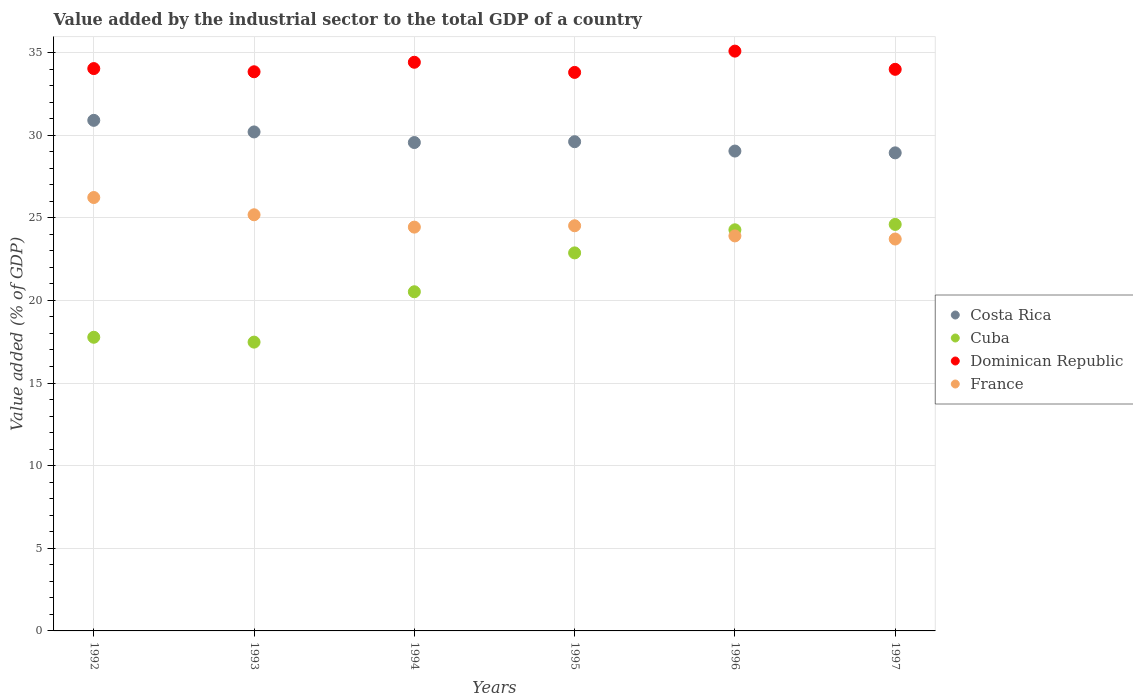How many different coloured dotlines are there?
Your response must be concise. 4. Is the number of dotlines equal to the number of legend labels?
Make the answer very short. Yes. What is the value added by the industrial sector to the total GDP in Dominican Republic in 1997?
Make the answer very short. 33.98. Across all years, what is the maximum value added by the industrial sector to the total GDP in Cuba?
Give a very brief answer. 24.6. Across all years, what is the minimum value added by the industrial sector to the total GDP in France?
Provide a succinct answer. 23.71. What is the total value added by the industrial sector to the total GDP in France in the graph?
Provide a succinct answer. 147.98. What is the difference between the value added by the industrial sector to the total GDP in Costa Rica in 1996 and that in 1997?
Provide a short and direct response. 0.11. What is the difference between the value added by the industrial sector to the total GDP in France in 1994 and the value added by the industrial sector to the total GDP in Dominican Republic in 1995?
Offer a very short reply. -9.36. What is the average value added by the industrial sector to the total GDP in Cuba per year?
Make the answer very short. 21.25. In the year 1997, what is the difference between the value added by the industrial sector to the total GDP in Dominican Republic and value added by the industrial sector to the total GDP in Costa Rica?
Make the answer very short. 5.05. In how many years, is the value added by the industrial sector to the total GDP in France greater than 7 %?
Your response must be concise. 6. What is the ratio of the value added by the industrial sector to the total GDP in Costa Rica in 1993 to that in 1995?
Give a very brief answer. 1.02. What is the difference between the highest and the second highest value added by the industrial sector to the total GDP in Dominican Republic?
Ensure brevity in your answer.  0.67. What is the difference between the highest and the lowest value added by the industrial sector to the total GDP in France?
Make the answer very short. 2.51. In how many years, is the value added by the industrial sector to the total GDP in Cuba greater than the average value added by the industrial sector to the total GDP in Cuba taken over all years?
Ensure brevity in your answer.  3. Is the sum of the value added by the industrial sector to the total GDP in Cuba in 1992 and 1994 greater than the maximum value added by the industrial sector to the total GDP in Dominican Republic across all years?
Provide a succinct answer. Yes. Is it the case that in every year, the sum of the value added by the industrial sector to the total GDP in Cuba and value added by the industrial sector to the total GDP in Dominican Republic  is greater than the sum of value added by the industrial sector to the total GDP in Costa Rica and value added by the industrial sector to the total GDP in France?
Provide a short and direct response. No. Is the value added by the industrial sector to the total GDP in Cuba strictly greater than the value added by the industrial sector to the total GDP in Dominican Republic over the years?
Keep it short and to the point. No. How many dotlines are there?
Make the answer very short. 4. How many years are there in the graph?
Your answer should be very brief. 6. How many legend labels are there?
Your response must be concise. 4. How are the legend labels stacked?
Your answer should be very brief. Vertical. What is the title of the graph?
Keep it short and to the point. Value added by the industrial sector to the total GDP of a country. Does "Seychelles" appear as one of the legend labels in the graph?
Your response must be concise. No. What is the label or title of the Y-axis?
Provide a short and direct response. Value added (% of GDP). What is the Value added (% of GDP) of Costa Rica in 1992?
Offer a terse response. 30.9. What is the Value added (% of GDP) of Cuba in 1992?
Your response must be concise. 17.77. What is the Value added (% of GDP) in Dominican Republic in 1992?
Provide a short and direct response. 34.03. What is the Value added (% of GDP) in France in 1992?
Give a very brief answer. 26.23. What is the Value added (% of GDP) in Costa Rica in 1993?
Offer a very short reply. 30.19. What is the Value added (% of GDP) in Cuba in 1993?
Provide a short and direct response. 17.48. What is the Value added (% of GDP) of Dominican Republic in 1993?
Your response must be concise. 33.84. What is the Value added (% of GDP) of France in 1993?
Your answer should be compact. 25.18. What is the Value added (% of GDP) in Costa Rica in 1994?
Your answer should be compact. 29.55. What is the Value added (% of GDP) of Cuba in 1994?
Provide a succinct answer. 20.52. What is the Value added (% of GDP) of Dominican Republic in 1994?
Ensure brevity in your answer.  34.41. What is the Value added (% of GDP) in France in 1994?
Offer a very short reply. 24.43. What is the Value added (% of GDP) in Costa Rica in 1995?
Give a very brief answer. 29.6. What is the Value added (% of GDP) in Cuba in 1995?
Provide a succinct answer. 22.88. What is the Value added (% of GDP) of Dominican Republic in 1995?
Give a very brief answer. 33.8. What is the Value added (% of GDP) of France in 1995?
Your response must be concise. 24.52. What is the Value added (% of GDP) in Costa Rica in 1996?
Your response must be concise. 29.04. What is the Value added (% of GDP) of Cuba in 1996?
Your answer should be very brief. 24.27. What is the Value added (% of GDP) of Dominican Republic in 1996?
Your response must be concise. 35.08. What is the Value added (% of GDP) in France in 1996?
Keep it short and to the point. 23.9. What is the Value added (% of GDP) in Costa Rica in 1997?
Provide a succinct answer. 28.93. What is the Value added (% of GDP) in Cuba in 1997?
Provide a succinct answer. 24.6. What is the Value added (% of GDP) in Dominican Republic in 1997?
Offer a terse response. 33.98. What is the Value added (% of GDP) of France in 1997?
Give a very brief answer. 23.71. Across all years, what is the maximum Value added (% of GDP) of Costa Rica?
Your response must be concise. 30.9. Across all years, what is the maximum Value added (% of GDP) of Cuba?
Provide a short and direct response. 24.6. Across all years, what is the maximum Value added (% of GDP) in Dominican Republic?
Offer a very short reply. 35.08. Across all years, what is the maximum Value added (% of GDP) in France?
Your answer should be compact. 26.23. Across all years, what is the minimum Value added (% of GDP) in Costa Rica?
Give a very brief answer. 28.93. Across all years, what is the minimum Value added (% of GDP) in Cuba?
Keep it short and to the point. 17.48. Across all years, what is the minimum Value added (% of GDP) in Dominican Republic?
Make the answer very short. 33.8. Across all years, what is the minimum Value added (% of GDP) in France?
Make the answer very short. 23.71. What is the total Value added (% of GDP) in Costa Rica in the graph?
Make the answer very short. 178.21. What is the total Value added (% of GDP) of Cuba in the graph?
Ensure brevity in your answer.  127.51. What is the total Value added (% of GDP) of Dominican Republic in the graph?
Ensure brevity in your answer.  205.14. What is the total Value added (% of GDP) of France in the graph?
Provide a short and direct response. 147.97. What is the difference between the Value added (% of GDP) in Costa Rica in 1992 and that in 1993?
Keep it short and to the point. 0.7. What is the difference between the Value added (% of GDP) of Cuba in 1992 and that in 1993?
Make the answer very short. 0.29. What is the difference between the Value added (% of GDP) of Dominican Republic in 1992 and that in 1993?
Offer a very short reply. 0.19. What is the difference between the Value added (% of GDP) in France in 1992 and that in 1993?
Your answer should be compact. 1.04. What is the difference between the Value added (% of GDP) of Costa Rica in 1992 and that in 1994?
Make the answer very short. 1.34. What is the difference between the Value added (% of GDP) of Cuba in 1992 and that in 1994?
Your response must be concise. -2.75. What is the difference between the Value added (% of GDP) of Dominican Republic in 1992 and that in 1994?
Offer a terse response. -0.38. What is the difference between the Value added (% of GDP) of France in 1992 and that in 1994?
Your answer should be very brief. 1.79. What is the difference between the Value added (% of GDP) of Costa Rica in 1992 and that in 1995?
Give a very brief answer. 1.29. What is the difference between the Value added (% of GDP) of Cuba in 1992 and that in 1995?
Your answer should be very brief. -5.11. What is the difference between the Value added (% of GDP) in Dominican Republic in 1992 and that in 1995?
Provide a succinct answer. 0.23. What is the difference between the Value added (% of GDP) in France in 1992 and that in 1995?
Ensure brevity in your answer.  1.71. What is the difference between the Value added (% of GDP) of Costa Rica in 1992 and that in 1996?
Provide a short and direct response. 1.86. What is the difference between the Value added (% of GDP) of Cuba in 1992 and that in 1996?
Your answer should be very brief. -6.5. What is the difference between the Value added (% of GDP) of Dominican Republic in 1992 and that in 1996?
Provide a succinct answer. -1.06. What is the difference between the Value added (% of GDP) in France in 1992 and that in 1996?
Provide a short and direct response. 2.32. What is the difference between the Value added (% of GDP) in Costa Rica in 1992 and that in 1997?
Provide a succinct answer. 1.97. What is the difference between the Value added (% of GDP) of Cuba in 1992 and that in 1997?
Ensure brevity in your answer.  -6.83. What is the difference between the Value added (% of GDP) in Dominican Republic in 1992 and that in 1997?
Your response must be concise. 0.05. What is the difference between the Value added (% of GDP) in France in 1992 and that in 1997?
Offer a very short reply. 2.51. What is the difference between the Value added (% of GDP) of Costa Rica in 1993 and that in 1994?
Make the answer very short. 0.64. What is the difference between the Value added (% of GDP) in Cuba in 1993 and that in 1994?
Ensure brevity in your answer.  -3.05. What is the difference between the Value added (% of GDP) in Dominican Republic in 1993 and that in 1994?
Give a very brief answer. -0.57. What is the difference between the Value added (% of GDP) of France in 1993 and that in 1994?
Provide a short and direct response. 0.75. What is the difference between the Value added (% of GDP) in Costa Rica in 1993 and that in 1995?
Your answer should be compact. 0.59. What is the difference between the Value added (% of GDP) in Cuba in 1993 and that in 1995?
Provide a succinct answer. -5.4. What is the difference between the Value added (% of GDP) of Dominican Republic in 1993 and that in 1995?
Provide a short and direct response. 0.04. What is the difference between the Value added (% of GDP) in France in 1993 and that in 1995?
Your answer should be compact. 0.66. What is the difference between the Value added (% of GDP) of Costa Rica in 1993 and that in 1996?
Keep it short and to the point. 1.16. What is the difference between the Value added (% of GDP) of Cuba in 1993 and that in 1996?
Ensure brevity in your answer.  -6.8. What is the difference between the Value added (% of GDP) in Dominican Republic in 1993 and that in 1996?
Your answer should be compact. -1.25. What is the difference between the Value added (% of GDP) of France in 1993 and that in 1996?
Make the answer very short. 1.28. What is the difference between the Value added (% of GDP) of Costa Rica in 1993 and that in 1997?
Make the answer very short. 1.27. What is the difference between the Value added (% of GDP) in Cuba in 1993 and that in 1997?
Ensure brevity in your answer.  -7.12. What is the difference between the Value added (% of GDP) in Dominican Republic in 1993 and that in 1997?
Provide a succinct answer. -0.15. What is the difference between the Value added (% of GDP) of France in 1993 and that in 1997?
Provide a succinct answer. 1.47. What is the difference between the Value added (% of GDP) in Costa Rica in 1994 and that in 1995?
Provide a succinct answer. -0.05. What is the difference between the Value added (% of GDP) of Cuba in 1994 and that in 1995?
Give a very brief answer. -2.35. What is the difference between the Value added (% of GDP) of Dominican Republic in 1994 and that in 1995?
Your answer should be compact. 0.61. What is the difference between the Value added (% of GDP) of France in 1994 and that in 1995?
Make the answer very short. -0.08. What is the difference between the Value added (% of GDP) of Costa Rica in 1994 and that in 1996?
Provide a short and direct response. 0.52. What is the difference between the Value added (% of GDP) in Cuba in 1994 and that in 1996?
Your answer should be compact. -3.75. What is the difference between the Value added (% of GDP) in Dominican Republic in 1994 and that in 1996?
Provide a succinct answer. -0.67. What is the difference between the Value added (% of GDP) of France in 1994 and that in 1996?
Your answer should be very brief. 0.53. What is the difference between the Value added (% of GDP) in Costa Rica in 1994 and that in 1997?
Make the answer very short. 0.62. What is the difference between the Value added (% of GDP) of Cuba in 1994 and that in 1997?
Make the answer very short. -4.08. What is the difference between the Value added (% of GDP) of Dominican Republic in 1994 and that in 1997?
Provide a succinct answer. 0.43. What is the difference between the Value added (% of GDP) in France in 1994 and that in 1997?
Provide a short and direct response. 0.72. What is the difference between the Value added (% of GDP) of Costa Rica in 1995 and that in 1996?
Offer a terse response. 0.57. What is the difference between the Value added (% of GDP) in Cuba in 1995 and that in 1996?
Keep it short and to the point. -1.4. What is the difference between the Value added (% of GDP) in Dominican Republic in 1995 and that in 1996?
Provide a short and direct response. -1.29. What is the difference between the Value added (% of GDP) in France in 1995 and that in 1996?
Give a very brief answer. 0.61. What is the difference between the Value added (% of GDP) of Costa Rica in 1995 and that in 1997?
Offer a terse response. 0.67. What is the difference between the Value added (% of GDP) in Cuba in 1995 and that in 1997?
Offer a terse response. -1.72. What is the difference between the Value added (% of GDP) in Dominican Republic in 1995 and that in 1997?
Keep it short and to the point. -0.19. What is the difference between the Value added (% of GDP) in France in 1995 and that in 1997?
Offer a very short reply. 0.8. What is the difference between the Value added (% of GDP) in Costa Rica in 1996 and that in 1997?
Provide a succinct answer. 0.11. What is the difference between the Value added (% of GDP) in Cuba in 1996 and that in 1997?
Offer a very short reply. -0.33. What is the difference between the Value added (% of GDP) of Dominican Republic in 1996 and that in 1997?
Give a very brief answer. 1.1. What is the difference between the Value added (% of GDP) of France in 1996 and that in 1997?
Keep it short and to the point. 0.19. What is the difference between the Value added (% of GDP) in Costa Rica in 1992 and the Value added (% of GDP) in Cuba in 1993?
Your answer should be very brief. 13.42. What is the difference between the Value added (% of GDP) in Costa Rica in 1992 and the Value added (% of GDP) in Dominican Republic in 1993?
Make the answer very short. -2.94. What is the difference between the Value added (% of GDP) of Costa Rica in 1992 and the Value added (% of GDP) of France in 1993?
Provide a short and direct response. 5.71. What is the difference between the Value added (% of GDP) in Cuba in 1992 and the Value added (% of GDP) in Dominican Republic in 1993?
Keep it short and to the point. -16.07. What is the difference between the Value added (% of GDP) of Cuba in 1992 and the Value added (% of GDP) of France in 1993?
Your answer should be very brief. -7.41. What is the difference between the Value added (% of GDP) of Dominican Republic in 1992 and the Value added (% of GDP) of France in 1993?
Make the answer very short. 8.85. What is the difference between the Value added (% of GDP) in Costa Rica in 1992 and the Value added (% of GDP) in Cuba in 1994?
Offer a terse response. 10.37. What is the difference between the Value added (% of GDP) of Costa Rica in 1992 and the Value added (% of GDP) of Dominican Republic in 1994?
Your response must be concise. -3.51. What is the difference between the Value added (% of GDP) in Costa Rica in 1992 and the Value added (% of GDP) in France in 1994?
Ensure brevity in your answer.  6.46. What is the difference between the Value added (% of GDP) in Cuba in 1992 and the Value added (% of GDP) in Dominican Republic in 1994?
Ensure brevity in your answer.  -16.64. What is the difference between the Value added (% of GDP) of Cuba in 1992 and the Value added (% of GDP) of France in 1994?
Offer a terse response. -6.67. What is the difference between the Value added (% of GDP) of Dominican Republic in 1992 and the Value added (% of GDP) of France in 1994?
Give a very brief answer. 9.59. What is the difference between the Value added (% of GDP) of Costa Rica in 1992 and the Value added (% of GDP) of Cuba in 1995?
Your answer should be compact. 8.02. What is the difference between the Value added (% of GDP) in Costa Rica in 1992 and the Value added (% of GDP) in Dominican Republic in 1995?
Ensure brevity in your answer.  -2.9. What is the difference between the Value added (% of GDP) of Costa Rica in 1992 and the Value added (% of GDP) of France in 1995?
Your answer should be compact. 6.38. What is the difference between the Value added (% of GDP) in Cuba in 1992 and the Value added (% of GDP) in Dominican Republic in 1995?
Your answer should be compact. -16.03. What is the difference between the Value added (% of GDP) in Cuba in 1992 and the Value added (% of GDP) in France in 1995?
Ensure brevity in your answer.  -6.75. What is the difference between the Value added (% of GDP) of Dominican Republic in 1992 and the Value added (% of GDP) of France in 1995?
Your answer should be compact. 9.51. What is the difference between the Value added (% of GDP) in Costa Rica in 1992 and the Value added (% of GDP) in Cuba in 1996?
Provide a short and direct response. 6.62. What is the difference between the Value added (% of GDP) in Costa Rica in 1992 and the Value added (% of GDP) in Dominican Republic in 1996?
Give a very brief answer. -4.19. What is the difference between the Value added (% of GDP) of Costa Rica in 1992 and the Value added (% of GDP) of France in 1996?
Your response must be concise. 6.99. What is the difference between the Value added (% of GDP) of Cuba in 1992 and the Value added (% of GDP) of Dominican Republic in 1996?
Give a very brief answer. -17.31. What is the difference between the Value added (% of GDP) in Cuba in 1992 and the Value added (% of GDP) in France in 1996?
Offer a terse response. -6.13. What is the difference between the Value added (% of GDP) in Dominican Republic in 1992 and the Value added (% of GDP) in France in 1996?
Offer a terse response. 10.13. What is the difference between the Value added (% of GDP) of Costa Rica in 1992 and the Value added (% of GDP) of Cuba in 1997?
Your response must be concise. 6.3. What is the difference between the Value added (% of GDP) in Costa Rica in 1992 and the Value added (% of GDP) in Dominican Republic in 1997?
Ensure brevity in your answer.  -3.09. What is the difference between the Value added (% of GDP) of Costa Rica in 1992 and the Value added (% of GDP) of France in 1997?
Keep it short and to the point. 7.18. What is the difference between the Value added (% of GDP) of Cuba in 1992 and the Value added (% of GDP) of Dominican Republic in 1997?
Give a very brief answer. -16.21. What is the difference between the Value added (% of GDP) in Cuba in 1992 and the Value added (% of GDP) in France in 1997?
Make the answer very short. -5.94. What is the difference between the Value added (% of GDP) of Dominican Republic in 1992 and the Value added (% of GDP) of France in 1997?
Ensure brevity in your answer.  10.31. What is the difference between the Value added (% of GDP) in Costa Rica in 1993 and the Value added (% of GDP) in Cuba in 1994?
Keep it short and to the point. 9.67. What is the difference between the Value added (% of GDP) in Costa Rica in 1993 and the Value added (% of GDP) in Dominican Republic in 1994?
Your answer should be very brief. -4.22. What is the difference between the Value added (% of GDP) of Costa Rica in 1993 and the Value added (% of GDP) of France in 1994?
Provide a short and direct response. 5.76. What is the difference between the Value added (% of GDP) in Cuba in 1993 and the Value added (% of GDP) in Dominican Republic in 1994?
Your response must be concise. -16.93. What is the difference between the Value added (% of GDP) of Cuba in 1993 and the Value added (% of GDP) of France in 1994?
Give a very brief answer. -6.96. What is the difference between the Value added (% of GDP) in Dominican Republic in 1993 and the Value added (% of GDP) in France in 1994?
Your answer should be very brief. 9.4. What is the difference between the Value added (% of GDP) of Costa Rica in 1993 and the Value added (% of GDP) of Cuba in 1995?
Ensure brevity in your answer.  7.32. What is the difference between the Value added (% of GDP) in Costa Rica in 1993 and the Value added (% of GDP) in Dominican Republic in 1995?
Your response must be concise. -3.6. What is the difference between the Value added (% of GDP) of Costa Rica in 1993 and the Value added (% of GDP) of France in 1995?
Provide a short and direct response. 5.68. What is the difference between the Value added (% of GDP) of Cuba in 1993 and the Value added (% of GDP) of Dominican Republic in 1995?
Make the answer very short. -16.32. What is the difference between the Value added (% of GDP) in Cuba in 1993 and the Value added (% of GDP) in France in 1995?
Ensure brevity in your answer.  -7.04. What is the difference between the Value added (% of GDP) of Dominican Republic in 1993 and the Value added (% of GDP) of France in 1995?
Ensure brevity in your answer.  9.32. What is the difference between the Value added (% of GDP) of Costa Rica in 1993 and the Value added (% of GDP) of Cuba in 1996?
Your response must be concise. 5.92. What is the difference between the Value added (% of GDP) of Costa Rica in 1993 and the Value added (% of GDP) of Dominican Republic in 1996?
Keep it short and to the point. -4.89. What is the difference between the Value added (% of GDP) in Costa Rica in 1993 and the Value added (% of GDP) in France in 1996?
Offer a very short reply. 6.29. What is the difference between the Value added (% of GDP) in Cuba in 1993 and the Value added (% of GDP) in Dominican Republic in 1996?
Your answer should be compact. -17.61. What is the difference between the Value added (% of GDP) of Cuba in 1993 and the Value added (% of GDP) of France in 1996?
Provide a succinct answer. -6.43. What is the difference between the Value added (% of GDP) in Dominican Republic in 1993 and the Value added (% of GDP) in France in 1996?
Your answer should be very brief. 9.93. What is the difference between the Value added (% of GDP) of Costa Rica in 1993 and the Value added (% of GDP) of Cuba in 1997?
Your response must be concise. 5.6. What is the difference between the Value added (% of GDP) in Costa Rica in 1993 and the Value added (% of GDP) in Dominican Republic in 1997?
Your response must be concise. -3.79. What is the difference between the Value added (% of GDP) in Costa Rica in 1993 and the Value added (% of GDP) in France in 1997?
Provide a short and direct response. 6.48. What is the difference between the Value added (% of GDP) in Cuba in 1993 and the Value added (% of GDP) in Dominican Republic in 1997?
Offer a very short reply. -16.51. What is the difference between the Value added (% of GDP) of Cuba in 1993 and the Value added (% of GDP) of France in 1997?
Give a very brief answer. -6.24. What is the difference between the Value added (% of GDP) of Dominican Republic in 1993 and the Value added (% of GDP) of France in 1997?
Give a very brief answer. 10.12. What is the difference between the Value added (% of GDP) of Costa Rica in 1994 and the Value added (% of GDP) of Cuba in 1995?
Provide a succinct answer. 6.68. What is the difference between the Value added (% of GDP) in Costa Rica in 1994 and the Value added (% of GDP) in Dominican Republic in 1995?
Your response must be concise. -4.24. What is the difference between the Value added (% of GDP) of Costa Rica in 1994 and the Value added (% of GDP) of France in 1995?
Your response must be concise. 5.04. What is the difference between the Value added (% of GDP) in Cuba in 1994 and the Value added (% of GDP) in Dominican Republic in 1995?
Provide a succinct answer. -13.27. What is the difference between the Value added (% of GDP) in Cuba in 1994 and the Value added (% of GDP) in France in 1995?
Provide a short and direct response. -3.99. What is the difference between the Value added (% of GDP) in Dominican Republic in 1994 and the Value added (% of GDP) in France in 1995?
Your answer should be very brief. 9.89. What is the difference between the Value added (% of GDP) of Costa Rica in 1994 and the Value added (% of GDP) of Cuba in 1996?
Ensure brevity in your answer.  5.28. What is the difference between the Value added (% of GDP) of Costa Rica in 1994 and the Value added (% of GDP) of Dominican Republic in 1996?
Your answer should be very brief. -5.53. What is the difference between the Value added (% of GDP) in Costa Rica in 1994 and the Value added (% of GDP) in France in 1996?
Offer a very short reply. 5.65. What is the difference between the Value added (% of GDP) in Cuba in 1994 and the Value added (% of GDP) in Dominican Republic in 1996?
Make the answer very short. -14.56. What is the difference between the Value added (% of GDP) in Cuba in 1994 and the Value added (% of GDP) in France in 1996?
Keep it short and to the point. -3.38. What is the difference between the Value added (% of GDP) in Dominican Republic in 1994 and the Value added (% of GDP) in France in 1996?
Make the answer very short. 10.51. What is the difference between the Value added (% of GDP) in Costa Rica in 1994 and the Value added (% of GDP) in Cuba in 1997?
Provide a succinct answer. 4.95. What is the difference between the Value added (% of GDP) of Costa Rica in 1994 and the Value added (% of GDP) of Dominican Republic in 1997?
Provide a short and direct response. -4.43. What is the difference between the Value added (% of GDP) in Costa Rica in 1994 and the Value added (% of GDP) in France in 1997?
Your response must be concise. 5.84. What is the difference between the Value added (% of GDP) in Cuba in 1994 and the Value added (% of GDP) in Dominican Republic in 1997?
Your answer should be compact. -13.46. What is the difference between the Value added (% of GDP) of Cuba in 1994 and the Value added (% of GDP) of France in 1997?
Your answer should be compact. -3.19. What is the difference between the Value added (% of GDP) of Dominican Republic in 1994 and the Value added (% of GDP) of France in 1997?
Keep it short and to the point. 10.7. What is the difference between the Value added (% of GDP) of Costa Rica in 1995 and the Value added (% of GDP) of Cuba in 1996?
Offer a very short reply. 5.33. What is the difference between the Value added (% of GDP) of Costa Rica in 1995 and the Value added (% of GDP) of Dominican Republic in 1996?
Offer a very short reply. -5.48. What is the difference between the Value added (% of GDP) in Costa Rica in 1995 and the Value added (% of GDP) in France in 1996?
Keep it short and to the point. 5.7. What is the difference between the Value added (% of GDP) in Cuba in 1995 and the Value added (% of GDP) in Dominican Republic in 1996?
Offer a terse response. -12.21. What is the difference between the Value added (% of GDP) in Cuba in 1995 and the Value added (% of GDP) in France in 1996?
Your answer should be compact. -1.03. What is the difference between the Value added (% of GDP) in Dominican Republic in 1995 and the Value added (% of GDP) in France in 1996?
Ensure brevity in your answer.  9.89. What is the difference between the Value added (% of GDP) of Costa Rica in 1995 and the Value added (% of GDP) of Cuba in 1997?
Make the answer very short. 5. What is the difference between the Value added (% of GDP) in Costa Rica in 1995 and the Value added (% of GDP) in Dominican Republic in 1997?
Give a very brief answer. -4.38. What is the difference between the Value added (% of GDP) of Costa Rica in 1995 and the Value added (% of GDP) of France in 1997?
Provide a short and direct response. 5.89. What is the difference between the Value added (% of GDP) in Cuba in 1995 and the Value added (% of GDP) in Dominican Republic in 1997?
Keep it short and to the point. -11.11. What is the difference between the Value added (% of GDP) of Cuba in 1995 and the Value added (% of GDP) of France in 1997?
Your response must be concise. -0.84. What is the difference between the Value added (% of GDP) of Dominican Republic in 1995 and the Value added (% of GDP) of France in 1997?
Your answer should be compact. 10.08. What is the difference between the Value added (% of GDP) in Costa Rica in 1996 and the Value added (% of GDP) in Cuba in 1997?
Provide a short and direct response. 4.44. What is the difference between the Value added (% of GDP) in Costa Rica in 1996 and the Value added (% of GDP) in Dominican Republic in 1997?
Ensure brevity in your answer.  -4.95. What is the difference between the Value added (% of GDP) in Costa Rica in 1996 and the Value added (% of GDP) in France in 1997?
Ensure brevity in your answer.  5.32. What is the difference between the Value added (% of GDP) in Cuba in 1996 and the Value added (% of GDP) in Dominican Republic in 1997?
Make the answer very short. -9.71. What is the difference between the Value added (% of GDP) in Cuba in 1996 and the Value added (% of GDP) in France in 1997?
Give a very brief answer. 0.56. What is the difference between the Value added (% of GDP) of Dominican Republic in 1996 and the Value added (% of GDP) of France in 1997?
Your answer should be very brief. 11.37. What is the average Value added (% of GDP) of Costa Rica per year?
Your answer should be very brief. 29.7. What is the average Value added (% of GDP) of Cuba per year?
Offer a terse response. 21.25. What is the average Value added (% of GDP) in Dominican Republic per year?
Provide a succinct answer. 34.19. What is the average Value added (% of GDP) of France per year?
Make the answer very short. 24.66. In the year 1992, what is the difference between the Value added (% of GDP) in Costa Rica and Value added (% of GDP) in Cuba?
Your response must be concise. 13.13. In the year 1992, what is the difference between the Value added (% of GDP) in Costa Rica and Value added (% of GDP) in Dominican Republic?
Your answer should be very brief. -3.13. In the year 1992, what is the difference between the Value added (% of GDP) of Costa Rica and Value added (% of GDP) of France?
Offer a terse response. 4.67. In the year 1992, what is the difference between the Value added (% of GDP) of Cuba and Value added (% of GDP) of Dominican Republic?
Offer a very short reply. -16.26. In the year 1992, what is the difference between the Value added (% of GDP) in Cuba and Value added (% of GDP) in France?
Your response must be concise. -8.46. In the year 1992, what is the difference between the Value added (% of GDP) of Dominican Republic and Value added (% of GDP) of France?
Your response must be concise. 7.8. In the year 1993, what is the difference between the Value added (% of GDP) in Costa Rica and Value added (% of GDP) in Cuba?
Provide a succinct answer. 12.72. In the year 1993, what is the difference between the Value added (% of GDP) of Costa Rica and Value added (% of GDP) of Dominican Republic?
Make the answer very short. -3.64. In the year 1993, what is the difference between the Value added (% of GDP) in Costa Rica and Value added (% of GDP) in France?
Give a very brief answer. 5.01. In the year 1993, what is the difference between the Value added (% of GDP) of Cuba and Value added (% of GDP) of Dominican Republic?
Offer a very short reply. -16.36. In the year 1993, what is the difference between the Value added (% of GDP) of Cuba and Value added (% of GDP) of France?
Provide a short and direct response. -7.71. In the year 1993, what is the difference between the Value added (% of GDP) of Dominican Republic and Value added (% of GDP) of France?
Make the answer very short. 8.65. In the year 1994, what is the difference between the Value added (% of GDP) in Costa Rica and Value added (% of GDP) in Cuba?
Provide a short and direct response. 9.03. In the year 1994, what is the difference between the Value added (% of GDP) of Costa Rica and Value added (% of GDP) of Dominican Republic?
Make the answer very short. -4.86. In the year 1994, what is the difference between the Value added (% of GDP) of Costa Rica and Value added (% of GDP) of France?
Keep it short and to the point. 5.12. In the year 1994, what is the difference between the Value added (% of GDP) in Cuba and Value added (% of GDP) in Dominican Republic?
Ensure brevity in your answer.  -13.89. In the year 1994, what is the difference between the Value added (% of GDP) of Cuba and Value added (% of GDP) of France?
Provide a short and direct response. -3.91. In the year 1994, what is the difference between the Value added (% of GDP) of Dominican Republic and Value added (% of GDP) of France?
Ensure brevity in your answer.  9.98. In the year 1995, what is the difference between the Value added (% of GDP) in Costa Rica and Value added (% of GDP) in Cuba?
Keep it short and to the point. 6.73. In the year 1995, what is the difference between the Value added (% of GDP) in Costa Rica and Value added (% of GDP) in Dominican Republic?
Keep it short and to the point. -4.19. In the year 1995, what is the difference between the Value added (% of GDP) of Costa Rica and Value added (% of GDP) of France?
Your answer should be very brief. 5.09. In the year 1995, what is the difference between the Value added (% of GDP) of Cuba and Value added (% of GDP) of Dominican Republic?
Keep it short and to the point. -10.92. In the year 1995, what is the difference between the Value added (% of GDP) of Cuba and Value added (% of GDP) of France?
Provide a short and direct response. -1.64. In the year 1995, what is the difference between the Value added (% of GDP) in Dominican Republic and Value added (% of GDP) in France?
Make the answer very short. 9.28. In the year 1996, what is the difference between the Value added (% of GDP) of Costa Rica and Value added (% of GDP) of Cuba?
Keep it short and to the point. 4.76. In the year 1996, what is the difference between the Value added (% of GDP) of Costa Rica and Value added (% of GDP) of Dominican Republic?
Provide a succinct answer. -6.05. In the year 1996, what is the difference between the Value added (% of GDP) of Costa Rica and Value added (% of GDP) of France?
Keep it short and to the point. 5.13. In the year 1996, what is the difference between the Value added (% of GDP) in Cuba and Value added (% of GDP) in Dominican Republic?
Offer a very short reply. -10.81. In the year 1996, what is the difference between the Value added (% of GDP) of Cuba and Value added (% of GDP) of France?
Ensure brevity in your answer.  0.37. In the year 1996, what is the difference between the Value added (% of GDP) of Dominican Republic and Value added (% of GDP) of France?
Provide a succinct answer. 11.18. In the year 1997, what is the difference between the Value added (% of GDP) of Costa Rica and Value added (% of GDP) of Cuba?
Give a very brief answer. 4.33. In the year 1997, what is the difference between the Value added (% of GDP) of Costa Rica and Value added (% of GDP) of Dominican Republic?
Ensure brevity in your answer.  -5.05. In the year 1997, what is the difference between the Value added (% of GDP) of Costa Rica and Value added (% of GDP) of France?
Keep it short and to the point. 5.21. In the year 1997, what is the difference between the Value added (% of GDP) of Cuba and Value added (% of GDP) of Dominican Republic?
Make the answer very short. -9.38. In the year 1997, what is the difference between the Value added (% of GDP) of Cuba and Value added (% of GDP) of France?
Offer a terse response. 0.88. In the year 1997, what is the difference between the Value added (% of GDP) of Dominican Republic and Value added (% of GDP) of France?
Your answer should be compact. 10.27. What is the ratio of the Value added (% of GDP) in Costa Rica in 1992 to that in 1993?
Offer a terse response. 1.02. What is the ratio of the Value added (% of GDP) in Cuba in 1992 to that in 1993?
Ensure brevity in your answer.  1.02. What is the ratio of the Value added (% of GDP) of France in 1992 to that in 1993?
Your answer should be compact. 1.04. What is the ratio of the Value added (% of GDP) in Costa Rica in 1992 to that in 1994?
Ensure brevity in your answer.  1.05. What is the ratio of the Value added (% of GDP) in Cuba in 1992 to that in 1994?
Give a very brief answer. 0.87. What is the ratio of the Value added (% of GDP) of Dominican Republic in 1992 to that in 1994?
Provide a succinct answer. 0.99. What is the ratio of the Value added (% of GDP) in France in 1992 to that in 1994?
Give a very brief answer. 1.07. What is the ratio of the Value added (% of GDP) in Costa Rica in 1992 to that in 1995?
Keep it short and to the point. 1.04. What is the ratio of the Value added (% of GDP) of Cuba in 1992 to that in 1995?
Provide a succinct answer. 0.78. What is the ratio of the Value added (% of GDP) in Dominican Republic in 1992 to that in 1995?
Keep it short and to the point. 1.01. What is the ratio of the Value added (% of GDP) in France in 1992 to that in 1995?
Offer a terse response. 1.07. What is the ratio of the Value added (% of GDP) of Costa Rica in 1992 to that in 1996?
Keep it short and to the point. 1.06. What is the ratio of the Value added (% of GDP) of Cuba in 1992 to that in 1996?
Provide a succinct answer. 0.73. What is the ratio of the Value added (% of GDP) of Dominican Republic in 1992 to that in 1996?
Your answer should be very brief. 0.97. What is the ratio of the Value added (% of GDP) of France in 1992 to that in 1996?
Make the answer very short. 1.1. What is the ratio of the Value added (% of GDP) in Costa Rica in 1992 to that in 1997?
Keep it short and to the point. 1.07. What is the ratio of the Value added (% of GDP) of Cuba in 1992 to that in 1997?
Make the answer very short. 0.72. What is the ratio of the Value added (% of GDP) of France in 1992 to that in 1997?
Offer a terse response. 1.11. What is the ratio of the Value added (% of GDP) in Costa Rica in 1993 to that in 1994?
Make the answer very short. 1.02. What is the ratio of the Value added (% of GDP) in Cuba in 1993 to that in 1994?
Your answer should be compact. 0.85. What is the ratio of the Value added (% of GDP) in Dominican Republic in 1993 to that in 1994?
Provide a short and direct response. 0.98. What is the ratio of the Value added (% of GDP) in France in 1993 to that in 1994?
Your answer should be compact. 1.03. What is the ratio of the Value added (% of GDP) of Cuba in 1993 to that in 1995?
Offer a very short reply. 0.76. What is the ratio of the Value added (% of GDP) in France in 1993 to that in 1995?
Your answer should be compact. 1.03. What is the ratio of the Value added (% of GDP) of Costa Rica in 1993 to that in 1996?
Ensure brevity in your answer.  1.04. What is the ratio of the Value added (% of GDP) of Cuba in 1993 to that in 1996?
Offer a terse response. 0.72. What is the ratio of the Value added (% of GDP) in Dominican Republic in 1993 to that in 1996?
Your answer should be very brief. 0.96. What is the ratio of the Value added (% of GDP) in France in 1993 to that in 1996?
Your response must be concise. 1.05. What is the ratio of the Value added (% of GDP) of Costa Rica in 1993 to that in 1997?
Give a very brief answer. 1.04. What is the ratio of the Value added (% of GDP) of Cuba in 1993 to that in 1997?
Keep it short and to the point. 0.71. What is the ratio of the Value added (% of GDP) of France in 1993 to that in 1997?
Give a very brief answer. 1.06. What is the ratio of the Value added (% of GDP) in Costa Rica in 1994 to that in 1995?
Your answer should be very brief. 1. What is the ratio of the Value added (% of GDP) in Cuba in 1994 to that in 1995?
Keep it short and to the point. 0.9. What is the ratio of the Value added (% of GDP) of Dominican Republic in 1994 to that in 1995?
Provide a short and direct response. 1.02. What is the ratio of the Value added (% of GDP) in France in 1994 to that in 1995?
Keep it short and to the point. 1. What is the ratio of the Value added (% of GDP) in Costa Rica in 1994 to that in 1996?
Provide a short and direct response. 1.02. What is the ratio of the Value added (% of GDP) in Cuba in 1994 to that in 1996?
Offer a very short reply. 0.85. What is the ratio of the Value added (% of GDP) in Dominican Republic in 1994 to that in 1996?
Make the answer very short. 0.98. What is the ratio of the Value added (% of GDP) in France in 1994 to that in 1996?
Provide a short and direct response. 1.02. What is the ratio of the Value added (% of GDP) in Costa Rica in 1994 to that in 1997?
Provide a succinct answer. 1.02. What is the ratio of the Value added (% of GDP) in Cuba in 1994 to that in 1997?
Ensure brevity in your answer.  0.83. What is the ratio of the Value added (% of GDP) of Dominican Republic in 1994 to that in 1997?
Provide a short and direct response. 1.01. What is the ratio of the Value added (% of GDP) of France in 1994 to that in 1997?
Ensure brevity in your answer.  1.03. What is the ratio of the Value added (% of GDP) in Costa Rica in 1995 to that in 1996?
Your response must be concise. 1.02. What is the ratio of the Value added (% of GDP) of Cuba in 1995 to that in 1996?
Your answer should be very brief. 0.94. What is the ratio of the Value added (% of GDP) in Dominican Republic in 1995 to that in 1996?
Offer a terse response. 0.96. What is the ratio of the Value added (% of GDP) of France in 1995 to that in 1996?
Provide a succinct answer. 1.03. What is the ratio of the Value added (% of GDP) of Costa Rica in 1995 to that in 1997?
Offer a terse response. 1.02. What is the ratio of the Value added (% of GDP) of Cuba in 1995 to that in 1997?
Provide a short and direct response. 0.93. What is the ratio of the Value added (% of GDP) in France in 1995 to that in 1997?
Provide a succinct answer. 1.03. What is the ratio of the Value added (% of GDP) of Dominican Republic in 1996 to that in 1997?
Offer a terse response. 1.03. What is the difference between the highest and the second highest Value added (% of GDP) in Costa Rica?
Provide a succinct answer. 0.7. What is the difference between the highest and the second highest Value added (% of GDP) of Cuba?
Keep it short and to the point. 0.33. What is the difference between the highest and the second highest Value added (% of GDP) in Dominican Republic?
Offer a terse response. 0.67. What is the difference between the highest and the second highest Value added (% of GDP) in France?
Your answer should be very brief. 1.04. What is the difference between the highest and the lowest Value added (% of GDP) in Costa Rica?
Your response must be concise. 1.97. What is the difference between the highest and the lowest Value added (% of GDP) of Cuba?
Offer a very short reply. 7.12. What is the difference between the highest and the lowest Value added (% of GDP) in Dominican Republic?
Your answer should be very brief. 1.29. What is the difference between the highest and the lowest Value added (% of GDP) in France?
Give a very brief answer. 2.51. 